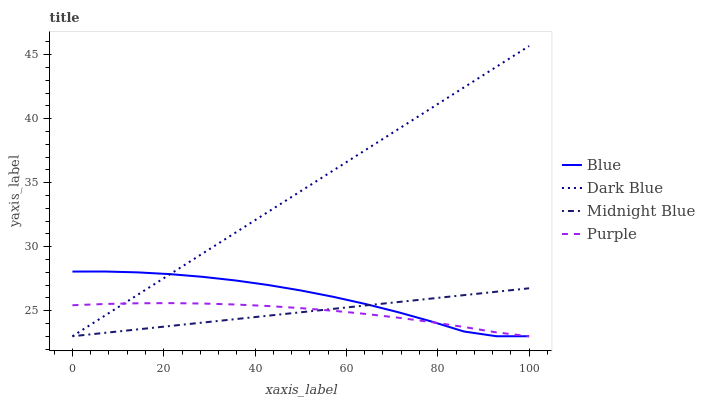Does Purple have the minimum area under the curve?
Answer yes or no. Yes. Does Dark Blue have the maximum area under the curve?
Answer yes or no. Yes. Does Midnight Blue have the minimum area under the curve?
Answer yes or no. No. Does Midnight Blue have the maximum area under the curve?
Answer yes or no. No. Is Midnight Blue the smoothest?
Answer yes or no. Yes. Is Blue the roughest?
Answer yes or no. Yes. Is Dark Blue the smoothest?
Answer yes or no. No. Is Dark Blue the roughest?
Answer yes or no. No. Does Blue have the lowest value?
Answer yes or no. Yes. Does Dark Blue have the highest value?
Answer yes or no. Yes. Does Midnight Blue have the highest value?
Answer yes or no. No. Does Midnight Blue intersect Purple?
Answer yes or no. Yes. Is Midnight Blue less than Purple?
Answer yes or no. No. Is Midnight Blue greater than Purple?
Answer yes or no. No. 